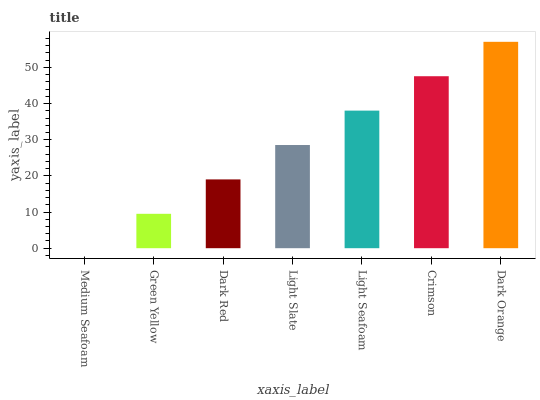Is Medium Seafoam the minimum?
Answer yes or no. Yes. Is Dark Orange the maximum?
Answer yes or no. Yes. Is Green Yellow the minimum?
Answer yes or no. No. Is Green Yellow the maximum?
Answer yes or no. No. Is Green Yellow greater than Medium Seafoam?
Answer yes or no. Yes. Is Medium Seafoam less than Green Yellow?
Answer yes or no. Yes. Is Medium Seafoam greater than Green Yellow?
Answer yes or no. No. Is Green Yellow less than Medium Seafoam?
Answer yes or no. No. Is Light Slate the high median?
Answer yes or no. Yes. Is Light Slate the low median?
Answer yes or no. Yes. Is Dark Orange the high median?
Answer yes or no. No. Is Dark Red the low median?
Answer yes or no. No. 